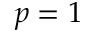Convert formula to latex. <formula><loc_0><loc_0><loc_500><loc_500>p = 1</formula> 